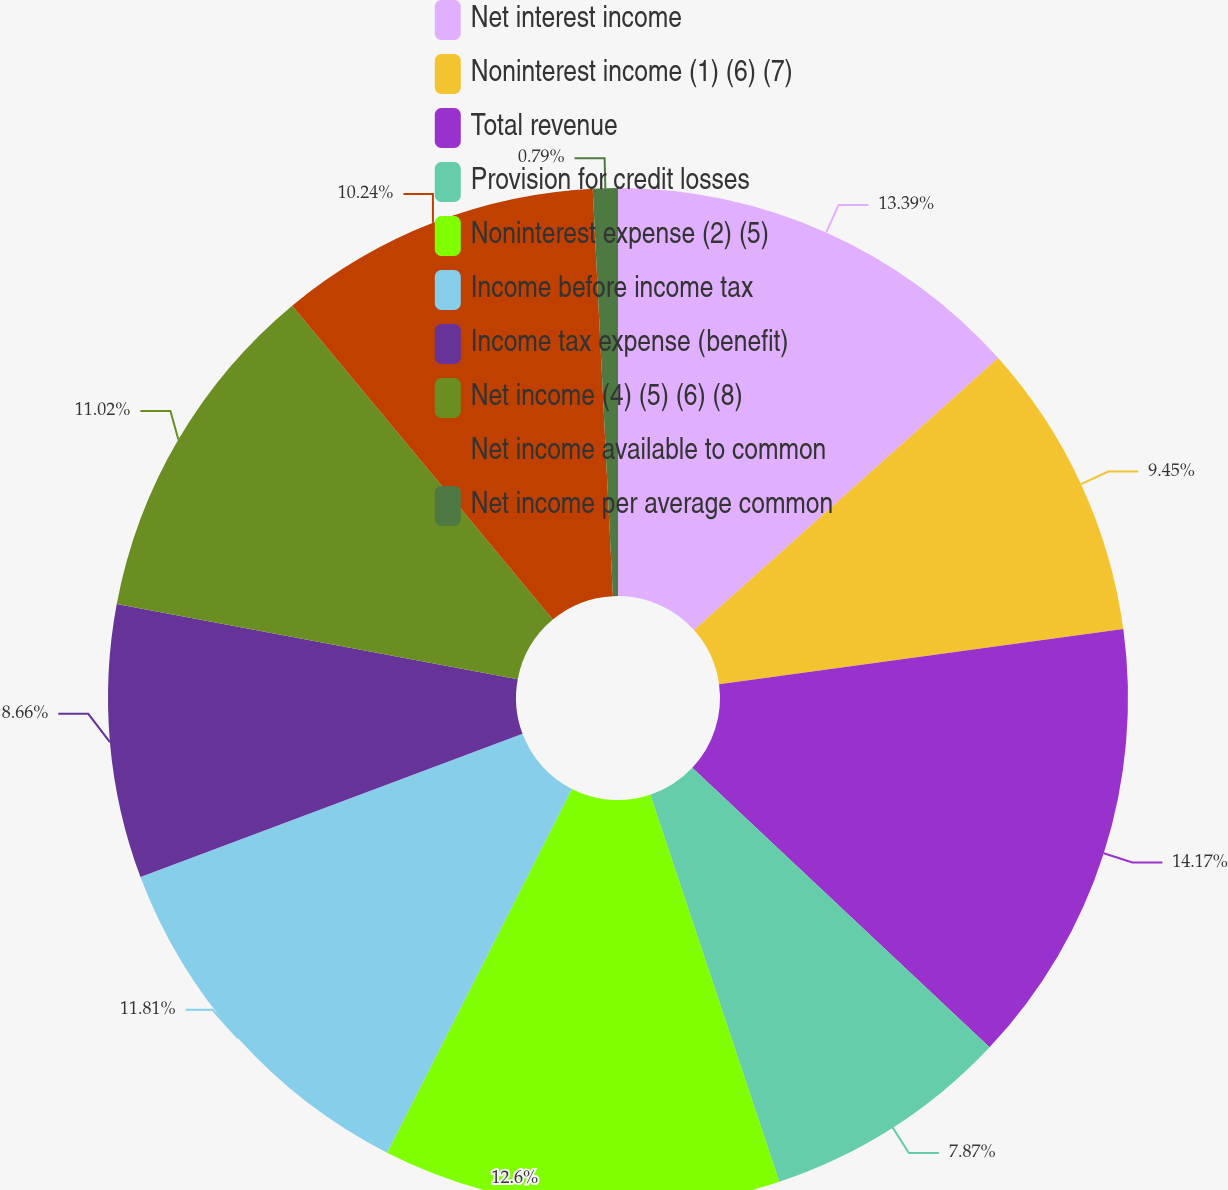Convert chart. <chart><loc_0><loc_0><loc_500><loc_500><pie_chart><fcel>Net interest income<fcel>Noninterest income (1) (6) (7)<fcel>Total revenue<fcel>Provision for credit losses<fcel>Noninterest expense (2) (5)<fcel>Income before income tax<fcel>Income tax expense (benefit)<fcel>Net income (4) (5) (6) (8)<fcel>Net income available to common<fcel>Net income per average common<nl><fcel>13.39%<fcel>9.45%<fcel>14.17%<fcel>7.87%<fcel>12.6%<fcel>11.81%<fcel>8.66%<fcel>11.02%<fcel>10.24%<fcel>0.79%<nl></chart> 